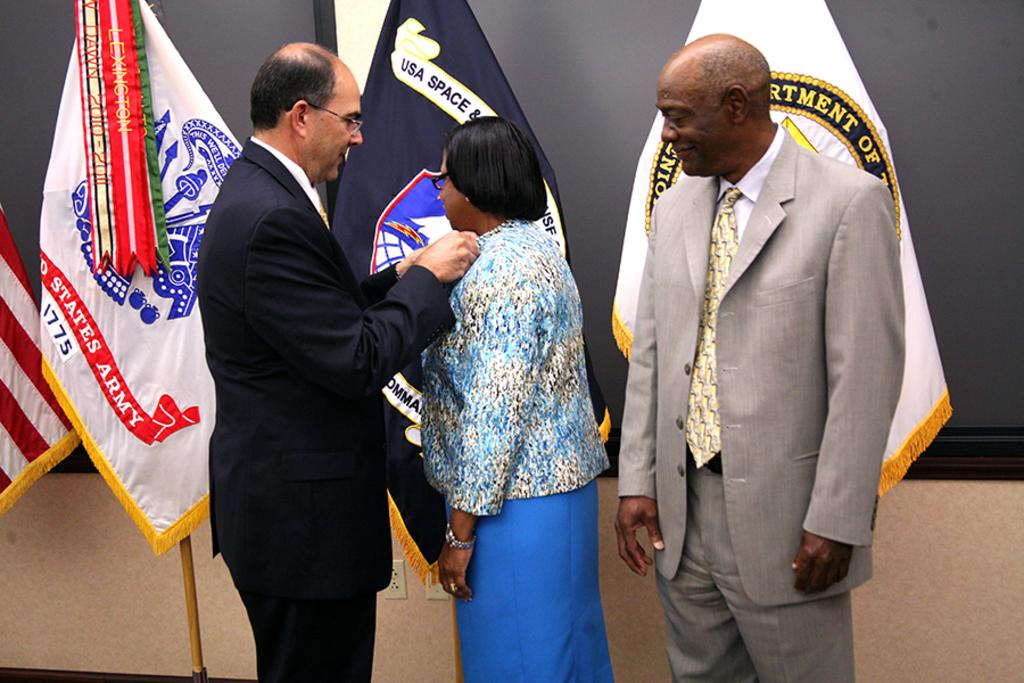How many people are in the image? There are two men and a woman in the image. What are the men wearing? The men are wearing suits. What can be seen in the background of the image? There are flags in the background of the image. What type of pear is being held by the woman in the image? There is no pear present in the image; the woman is not holding any fruit. What signs can be seen in the image? There are no signs visible in the image. 